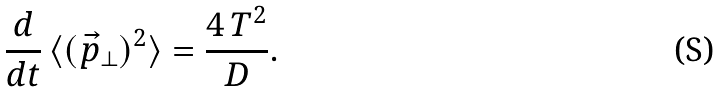<formula> <loc_0><loc_0><loc_500><loc_500>\frac { d } { d t } \, \langle ( \vec { p } _ { \perp } ) ^ { 2 } \rangle = \frac { 4 \, T ^ { 2 } } { D } .</formula> 